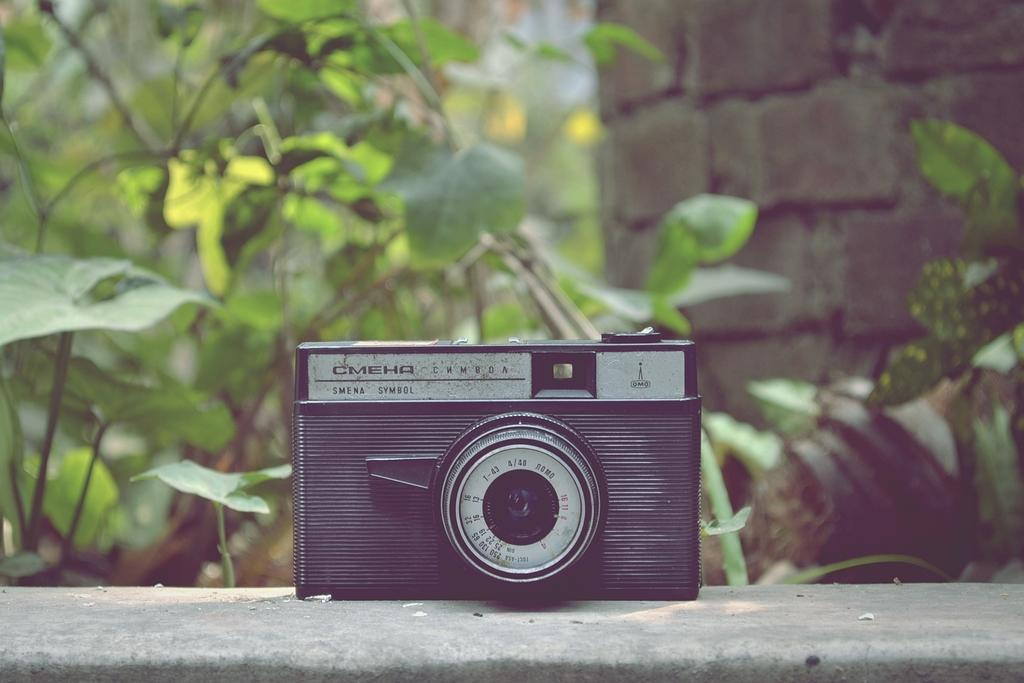Where was the image taken? The image was taken outside. What is the main subject in the middle of the image? There is a camera in the middle of the image. What type of natural elements can be seen in the image? There are plants visible in the image. What type of guitar is being played in the image? There is no guitar present in the image; it features a camera and plants. What type of competition is taking place in the image? There is no competition present in the image; it is a still image of a camera and plants. 